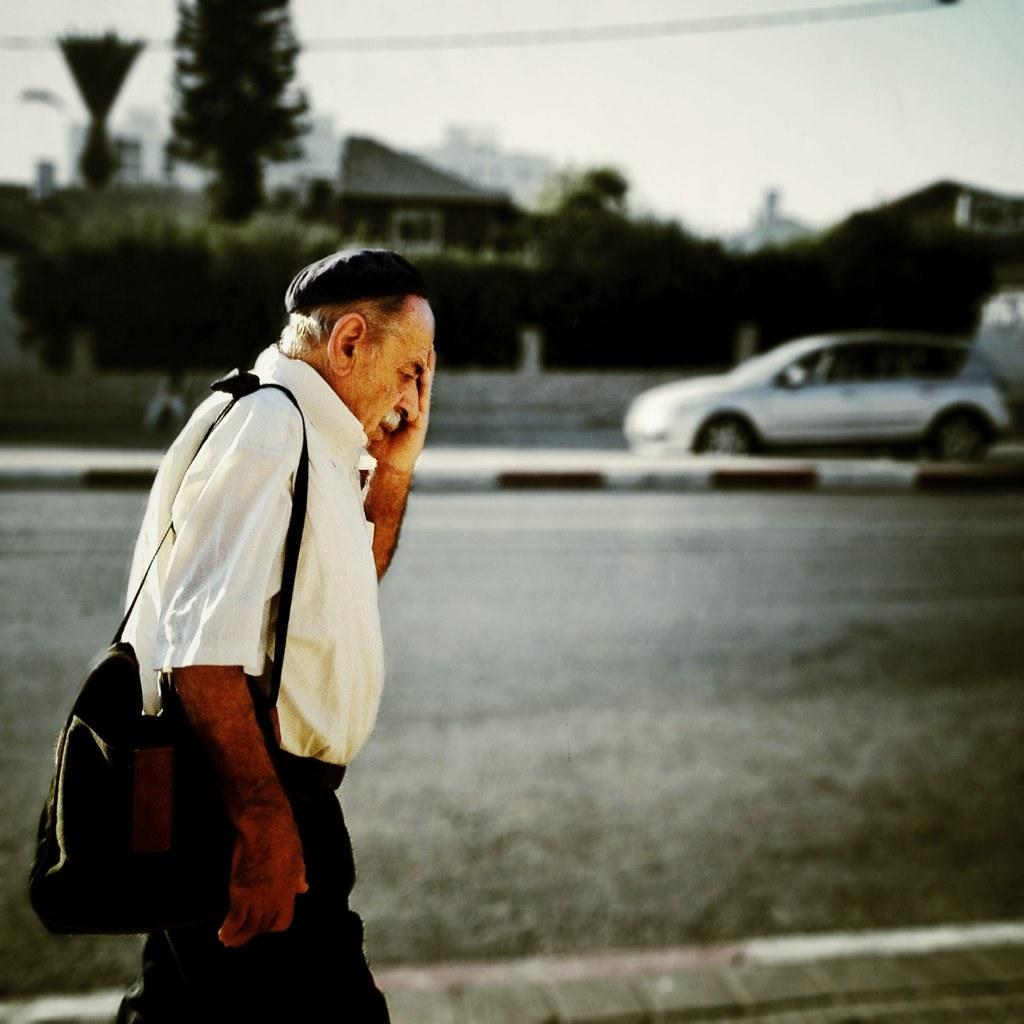What is the main subject of the image? There is a man in the image. Can you describe the man's clothing? The man is wearing a shirt and trousers. What is the man carrying in the image? The man is carrying a bag. What is the man doing in the image? The man is walking. What can be seen in the background of the image? There are trees, a car, cables, a house, a road, and the sky visible in the background of the image. Can you see any dinosaurs in the image? No, there are no dinosaurs present in the image. What type of guitar is the man playing in the image? There is no guitar present in the image; the man is simply walking with a bag. 